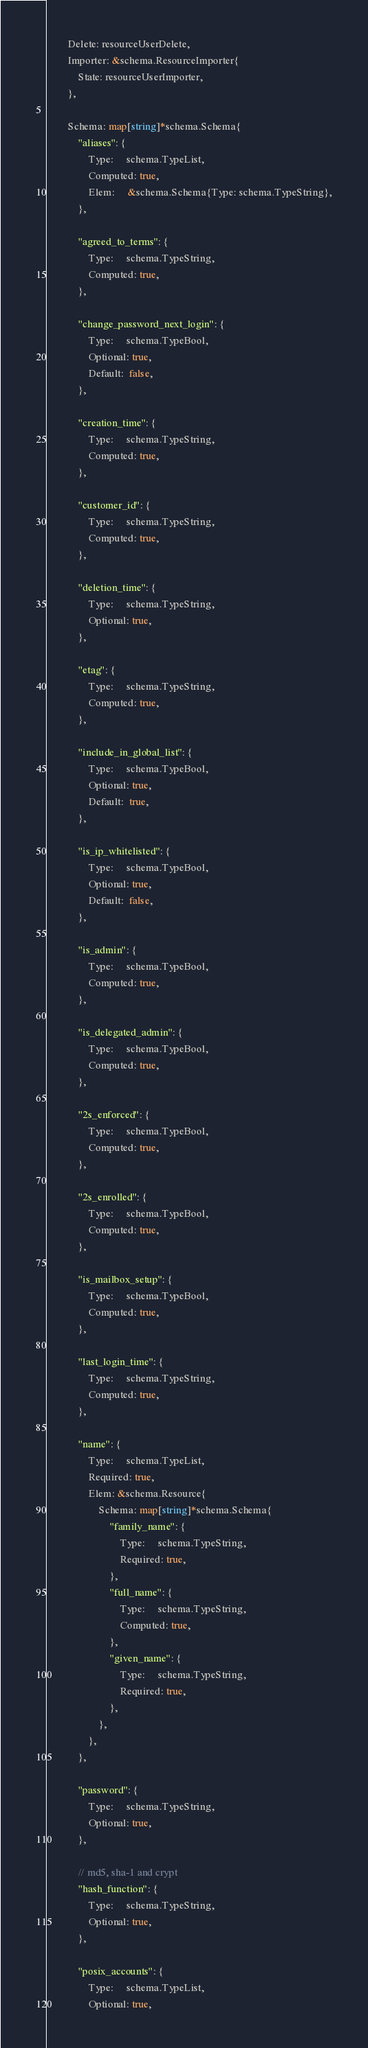Convert code to text. <code><loc_0><loc_0><loc_500><loc_500><_Go_>		Delete: resourceUserDelete,
		Importer: &schema.ResourceImporter{
			State: resourceUserImporter,
		},

		Schema: map[string]*schema.Schema{
			"aliases": {
				Type:     schema.TypeList,
				Computed: true,
				Elem:     &schema.Schema{Type: schema.TypeString},
			},

			"agreed_to_terms": {
				Type:     schema.TypeString,
				Computed: true,
			},

			"change_password_next_login": {
				Type:     schema.TypeBool,
				Optional: true,
				Default:  false,
			},

			"creation_time": {
				Type:     schema.TypeString,
				Computed: true,
			},

			"customer_id": {
				Type:     schema.TypeString,
				Computed: true,
			},

			"deletion_time": {
				Type:     schema.TypeString,
				Optional: true,
			},

			"etag": {
				Type:     schema.TypeString,
				Computed: true,
			},

			"include_in_global_list": {
				Type:     schema.TypeBool,
				Optional: true,
				Default:  true,
			},

			"is_ip_whitelisted": {
				Type:     schema.TypeBool,
				Optional: true,
				Default:  false,
			},

			"is_admin": {
				Type:     schema.TypeBool,
				Computed: true,
			},

			"is_delegated_admin": {
				Type:     schema.TypeBool,
				Computed: true,
			},

			"2s_enforced": {
				Type:     schema.TypeBool,
				Computed: true,
			},

			"2s_enrolled": {
				Type:     schema.TypeBool,
				Computed: true,
			},

			"is_mailbox_setup": {
				Type:     schema.TypeBool,
				Computed: true,
			},

			"last_login_time": {
				Type:     schema.TypeString,
				Computed: true,
			},

			"name": {
				Type:     schema.TypeList,
				Required: true,
				Elem: &schema.Resource{
					Schema: map[string]*schema.Schema{
						"family_name": {
							Type:     schema.TypeString,
							Required: true,
						},
						"full_name": {
							Type:     schema.TypeString,
							Computed: true,
						},
						"given_name": {
							Type:     schema.TypeString,
							Required: true,
						},
					},
				},
			},

			"password": {
				Type:     schema.TypeString,
				Optional: true,
			},

			// md5, sha-1 and crypt
			"hash_function": {
				Type:     schema.TypeString,
				Optional: true,
			},

			"posix_accounts": {
				Type:     schema.TypeList,
				Optional: true,</code> 